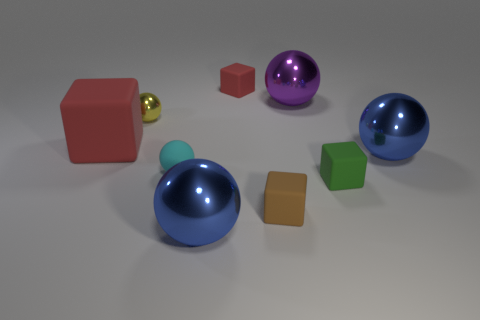How many blue spheres must be subtracted to get 1 blue spheres? 1 Subtract all purple metallic spheres. How many spheres are left? 4 Add 1 tiny green things. How many objects exist? 10 Subtract 2 cubes. How many cubes are left? 2 Subtract all yellow balls. How many balls are left? 4 Subtract all spheres. How many objects are left? 4 Subtract all red spheres. How many red cubes are left? 2 Subtract all large cyan matte blocks. Subtract all tiny red rubber cubes. How many objects are left? 8 Add 2 cyan things. How many cyan things are left? 3 Add 6 big blue matte cylinders. How many big blue matte cylinders exist? 6 